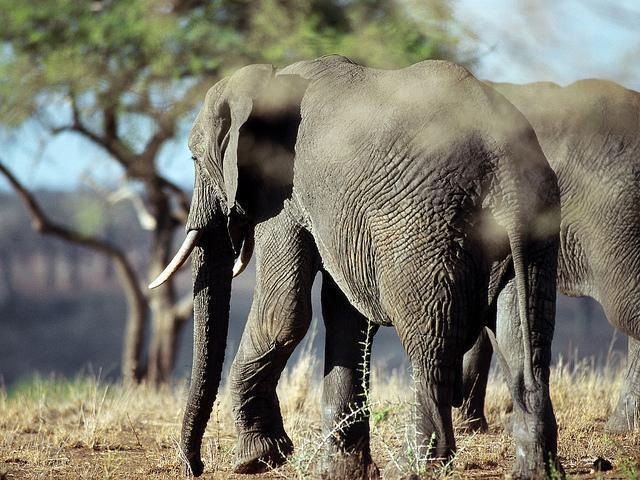How many elephants are there?
Give a very brief answer. 2. How many elephants can be seen?
Give a very brief answer. 2. 